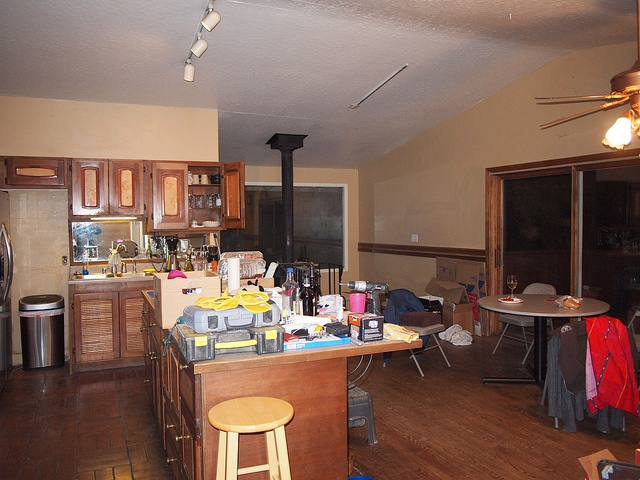Describe the objects in this image and their specific colors. I can see dining table in gray, brown, maroon, salmon, and tan tones, chair in gray, tan, khaki, and brown tones, dining table in gray, black, brown, and maroon tones, chair in gray, black, and maroon tones, and refrigerator in gray, black, and tan tones in this image. 